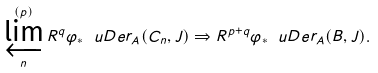Convert formula to latex. <formula><loc_0><loc_0><loc_500><loc_500>\varprojlim ^ { ( p ) } _ { n } R ^ { q } \varphi _ { \ast } \ u D e r _ { A } ( C _ { n } , J ) \Rightarrow R ^ { p + q } \varphi _ { \ast } \ u D e r _ { A } ( B , J ) .</formula> 